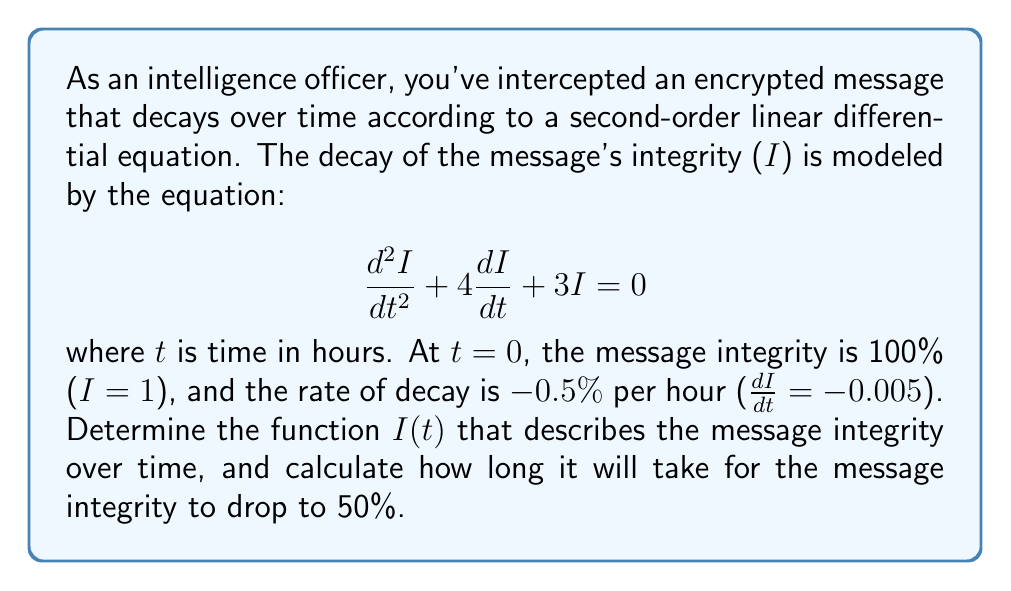Give your solution to this math problem. Let's solve this step-by-step:

1) We have a second-order linear differential equation:
   $$\frac{d^2I}{dt^2} + 4\frac{dI}{dt} + 3I = 0$$

2) The characteristic equation is:
   $$r^2 + 4r + 3 = 0$$

3) Solving this quadratic equation:
   $r = \frac{-4 \pm \sqrt{16 - 12}}{2} = \frac{-4 \pm 2}{2}$
   $r_1 = -1$ and $r_2 = -3$

4) The general solution is:
   $$I(t) = c_1e^{-t} + c_2e^{-3t}$$

5) We have two initial conditions:
   At $t = 0$, $I = 1$
   At $t = 0$, $\frac{dI}{dt} = -0.005$

6) Using the first condition:
   $1 = c_1 + c_2$

7) Using the second condition:
   $-0.005 = -c_1 - 3c_2$

8) Solving these simultaneous equations:
   $c_1 = 0.9975$ and $c_2 = 0.0025$

9) Therefore, the specific solution is:
   $$I(t) = 0.9975e^{-t} + 0.0025e^{-3t}$$

10) To find when I(t) = 0.5, we solve:
    $$0.5 = 0.9975e^{-t} + 0.0025e^{-3t}$$

11) This transcendental equation can't be solved algebraically. Using numerical methods (e.g., Newton-Raphson), we find:
    $t \approx 69.3$ hours
Answer: $I(t) = 0.9975e^{-t} + 0.0025e^{-3t}$; 69.3 hours 